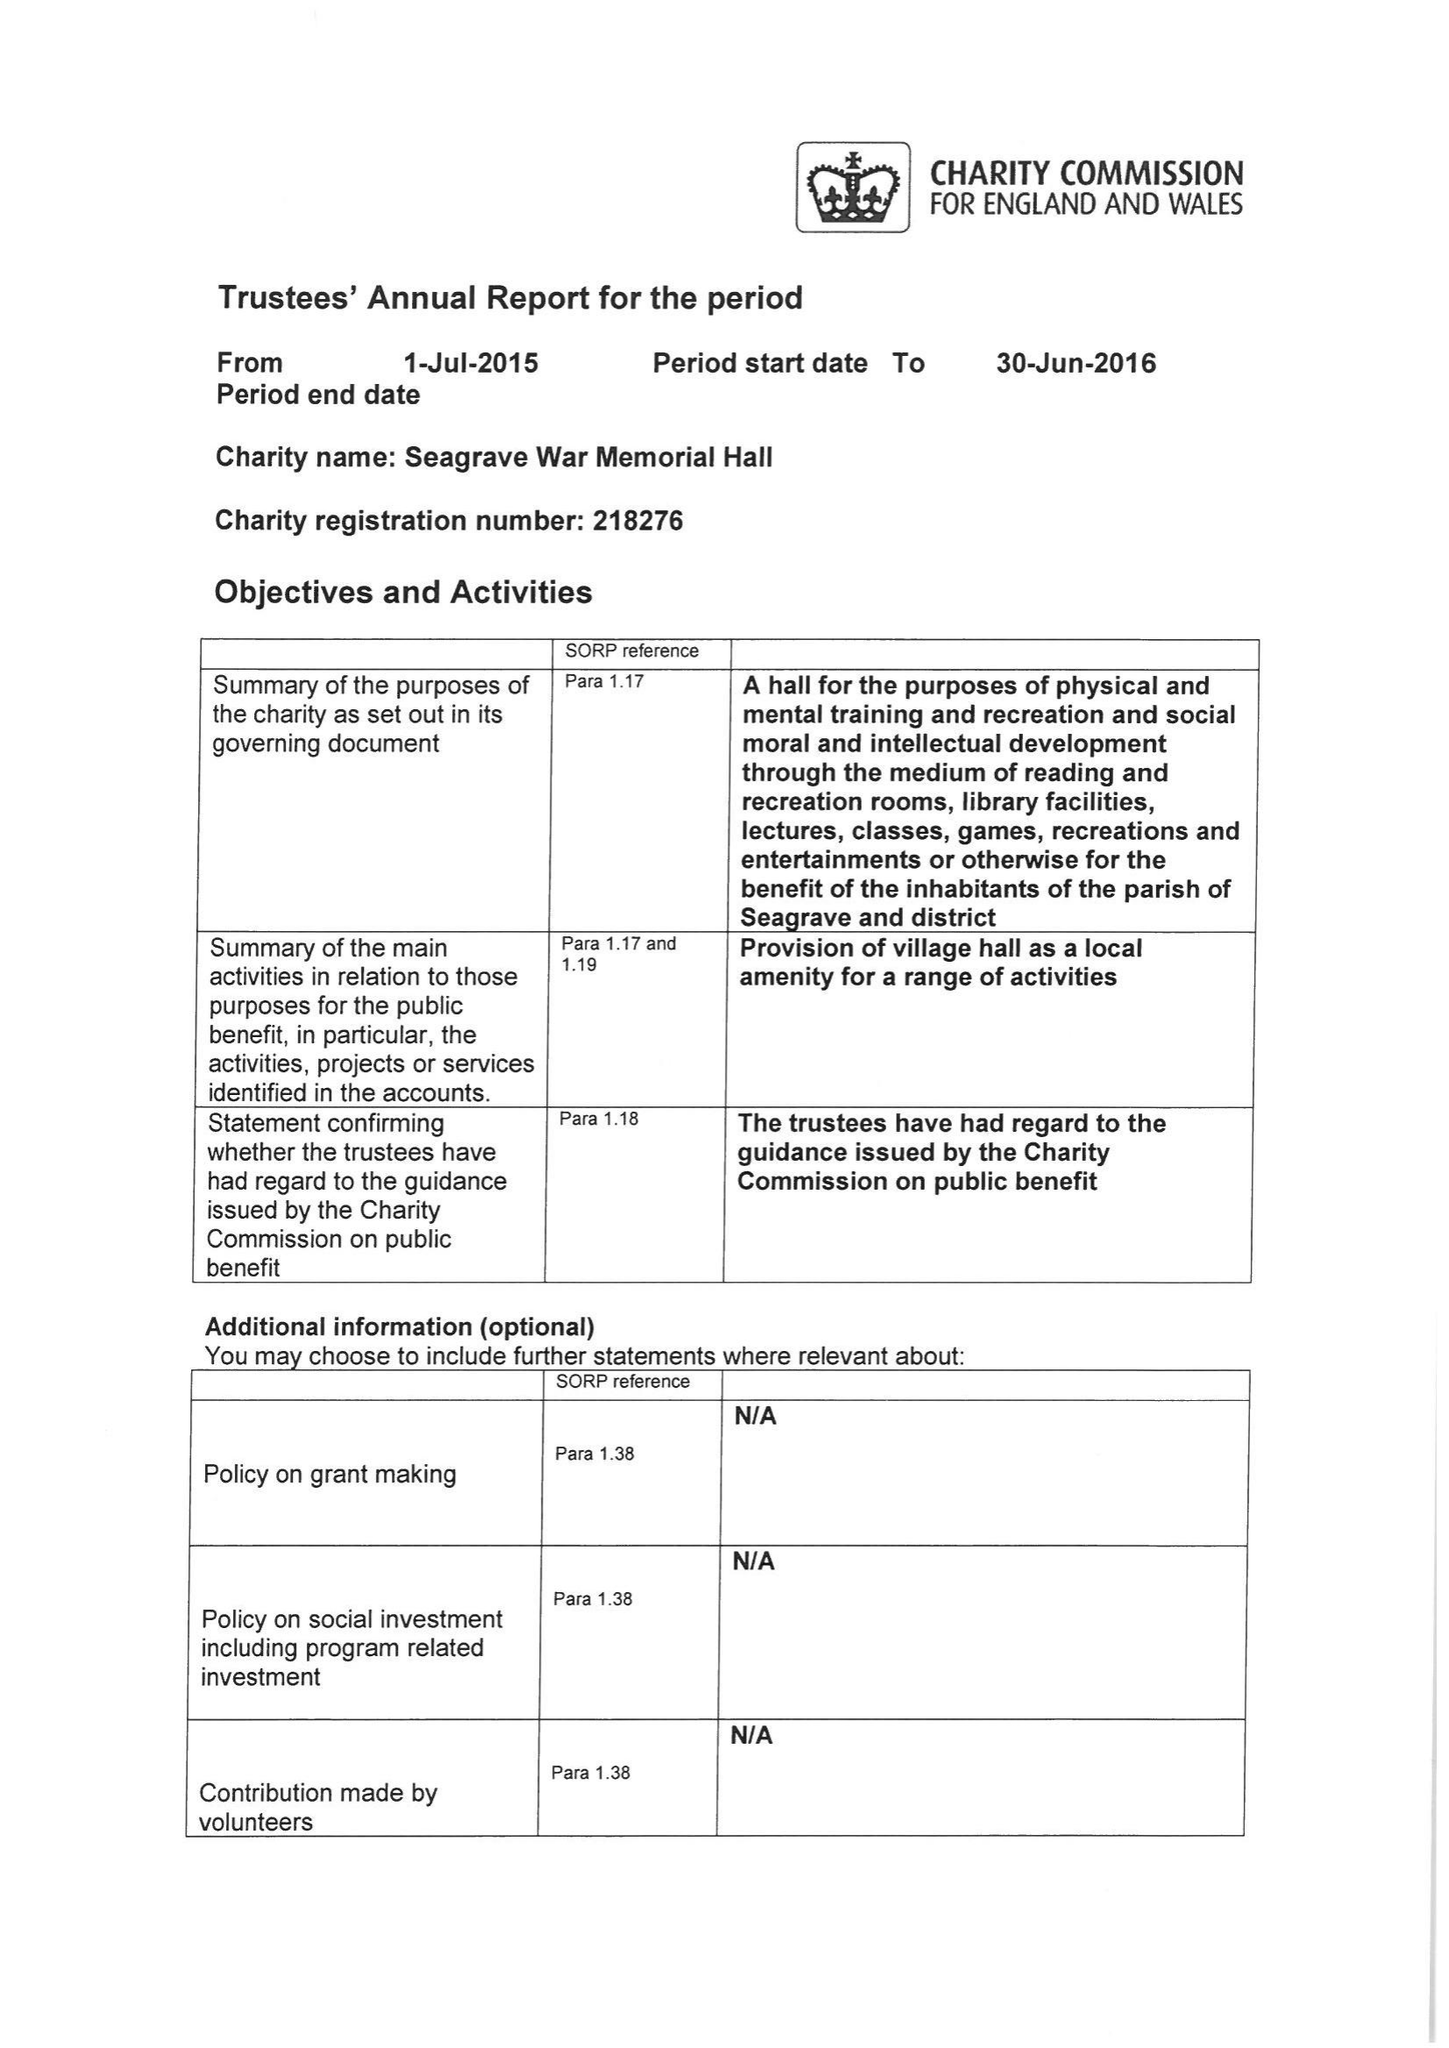What is the value for the charity_number?
Answer the question using a single word or phrase. 218276 